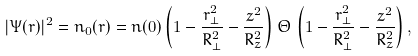<formula> <loc_0><loc_0><loc_500><loc_500>| \Psi ( { r } ) | ^ { 2 } = n _ { 0 } ( { r } ) = n ( 0 ) \left ( 1 - \frac { r _ { \perp } ^ { 2 } } { R _ { \perp } ^ { 2 } } - \frac { z ^ { 2 } } { R _ { z } ^ { 2 } } \right ) \, \Theta \, \left ( 1 - \frac { r _ { \perp } ^ { 2 } } { R _ { \perp } ^ { 2 } } - \frac { z ^ { 2 } } { R _ { z } ^ { 2 } } \right ) ,</formula> 